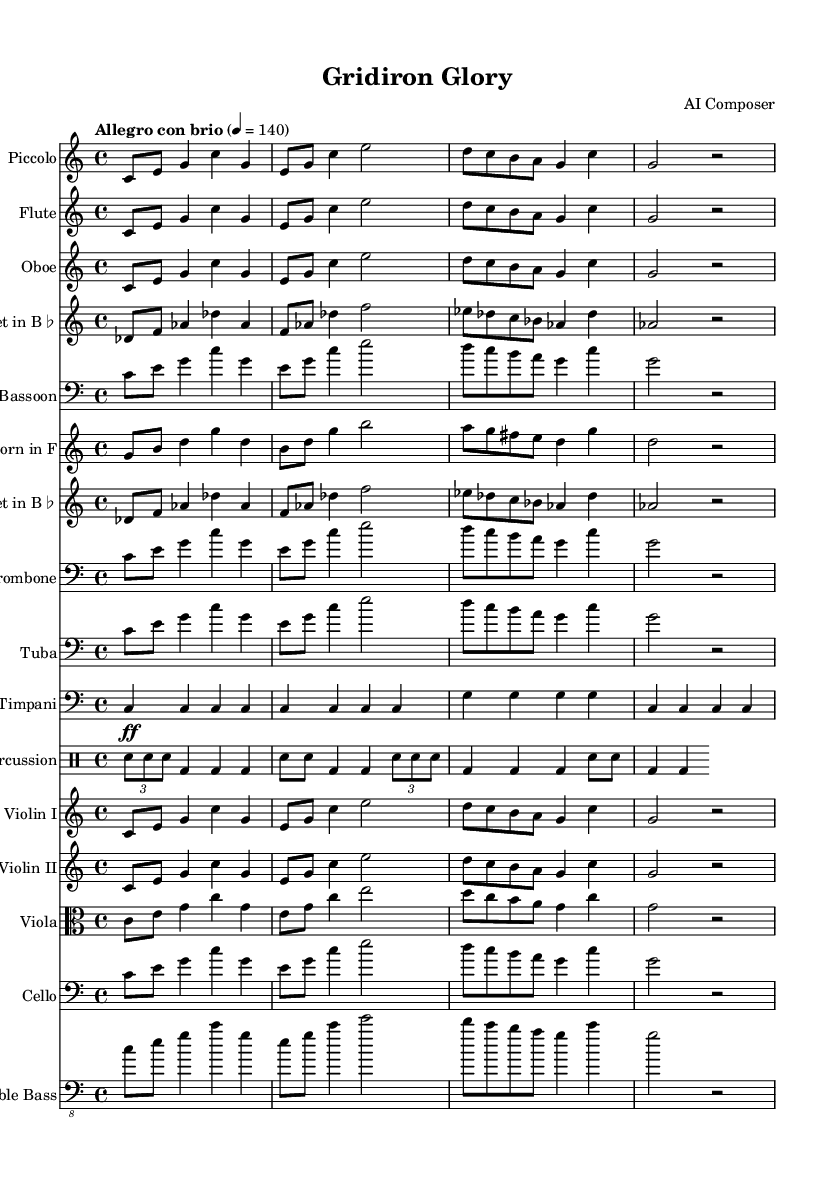What is the key signature of this music? The key signature is C major, which has no sharps or flats.
Answer: C major What is the time signature of this piece? The time signature indicates that there are four beats in a measure (4/4), meaning each measure gets a total of four quarter notes.
Answer: 4/4 What is the tempo marking of this composition? The tempo marking "Allegro con brio" suggests a lively and brisk pace, typically performed at a fast speed.
Answer: Allegro con brio How many different instruments are featured in the score? By counting the individual staffs, including percussion, there are fourteen distinct instruments indicated in the sheet music.
Answer: Fourteen What dynamic marking is used for the Timpani in the score? The Timpani part contains a fortissimo marking (ff), indicating that it should be played very loudly, enhancing the climactic feel of the piece.
Answer: Fortissimo Which instruments play the main theme in unison? The Piccolo, Flute, Oboe, and both Violins I and II all share the main theme, creating a rich, layered texture when played together.
Answer: Piccolo, Flute, Oboe, Violins I and II What rhythmic pattern is emphasized in the percussion section? The percussion section features a repeated rhythmic figure that alternates between snare and bass drums, creating a drive that aligns with the excitement of game day.
Answer: Alternating snare and bass 